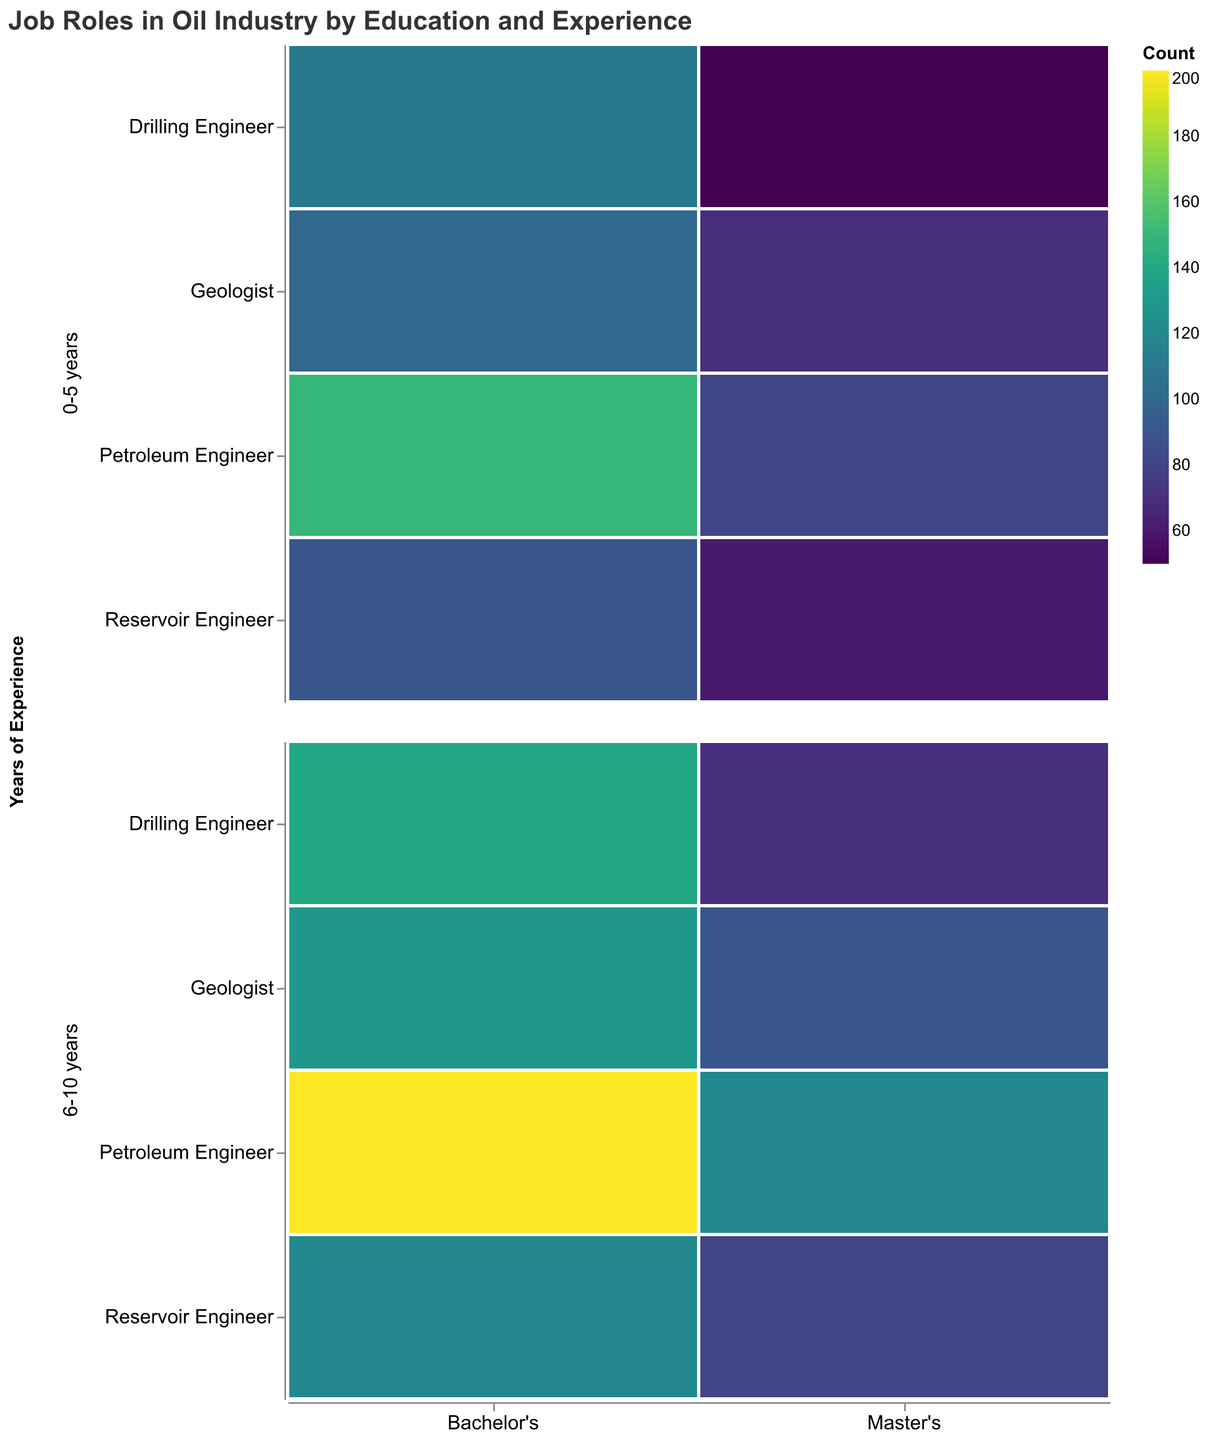What is the title of the plot? The title is located at the top of the plot and is written in a larger font size. It describes the content of the plot.
Answer: Job Roles in Oil Industry by Education and Experience What is the count of Geologists with Master's degrees and 6-10 years of experience? Look at the row for 6-10 years of experience, then find the section for Geologists with Master's degrees. The color intensity indicates the count.
Answer: 90 Which job role has the highest count with Bachelor's degrees and 6-10 years of experience? Look at the column for Bachelor's degrees and the row for 6-10 years of experience. Compare the color intensity for each job role.
Answer: Petroleum Engineer How many more Petroleum Engineers with Bachelor's degrees have 6-10 years of experience compared to 0-5 years? Find the counts for Petroleum Engineers with Bachelor's degrees in both experience ranges. Subtract the smaller count from the larger count.
Answer: 50 What is the total count of Drilling Engineers with 0-5 years of experience regardless of education level? Add the counts of Drilling Engineers with Bachelor's and Master's degrees for the 0-5 years experience range.
Answer: 160 Which education level has a generally higher count for Reservoir Engineers with 0-5 years of experience? Compare the color intensities for Bachelor's and Master's degrees within the 0-5 years of experience row for Reservoir Engineers.
Answer: Bachelor's Which job role shows a higher count for Master's degrees compared to Bachelor's degrees in the 0-5 years experience range? Compare the counts of Bachelor's and Master's degrees for each job role within the 0-5 years of experience row.
Answer: Geologist How many Petroleum Engineers in total have 0-5 years of experience? Add the counts of Petroleum Engineers with both education levels in the 0-5 years experience range.
Answer: 230 Which job role has the lowest count for Master's degrees and 6-10 years of experience? Compare the color intensities for each job role with Master's degrees in the 6-10 years of experience row.
Answer: Drilling Engineer What is the difference in count between Reservoir Engineers and Geologists with Bachelor's degrees and 6-10 years of experience? Subtract the count of Geologists from the count of Reservoir Engineers in the Bachelor's column for 6-10 years of experience.
Answer: 10 